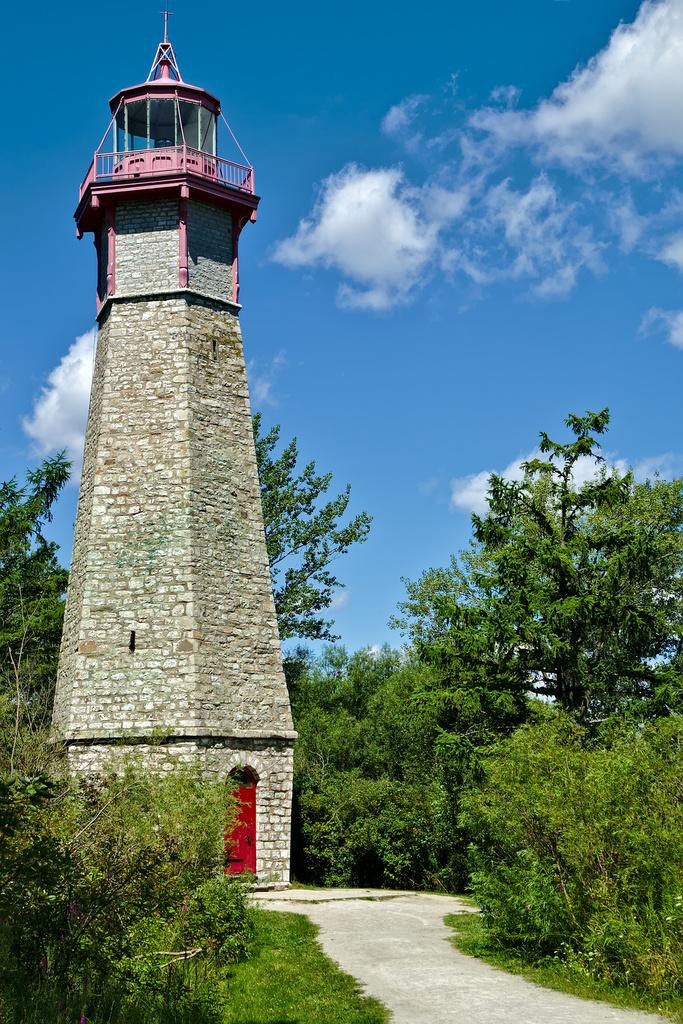What is the main structure in the image? There is a tower in the image. What is the color of the door in the image? There is a red door in the image. What can be seen leading to the tower in the image? There is a path visible in the image. What type of vegetation is present in the image? There are plants and trees in the image. What is visible in the background of the image? The sky is visible in the background of the image. What can be seen in the sky in the image? There are clouds in the sky. What type of vessel is being used to transport the clouds in the image? There is no vessel present in the image, and the clouds are not being transported. 